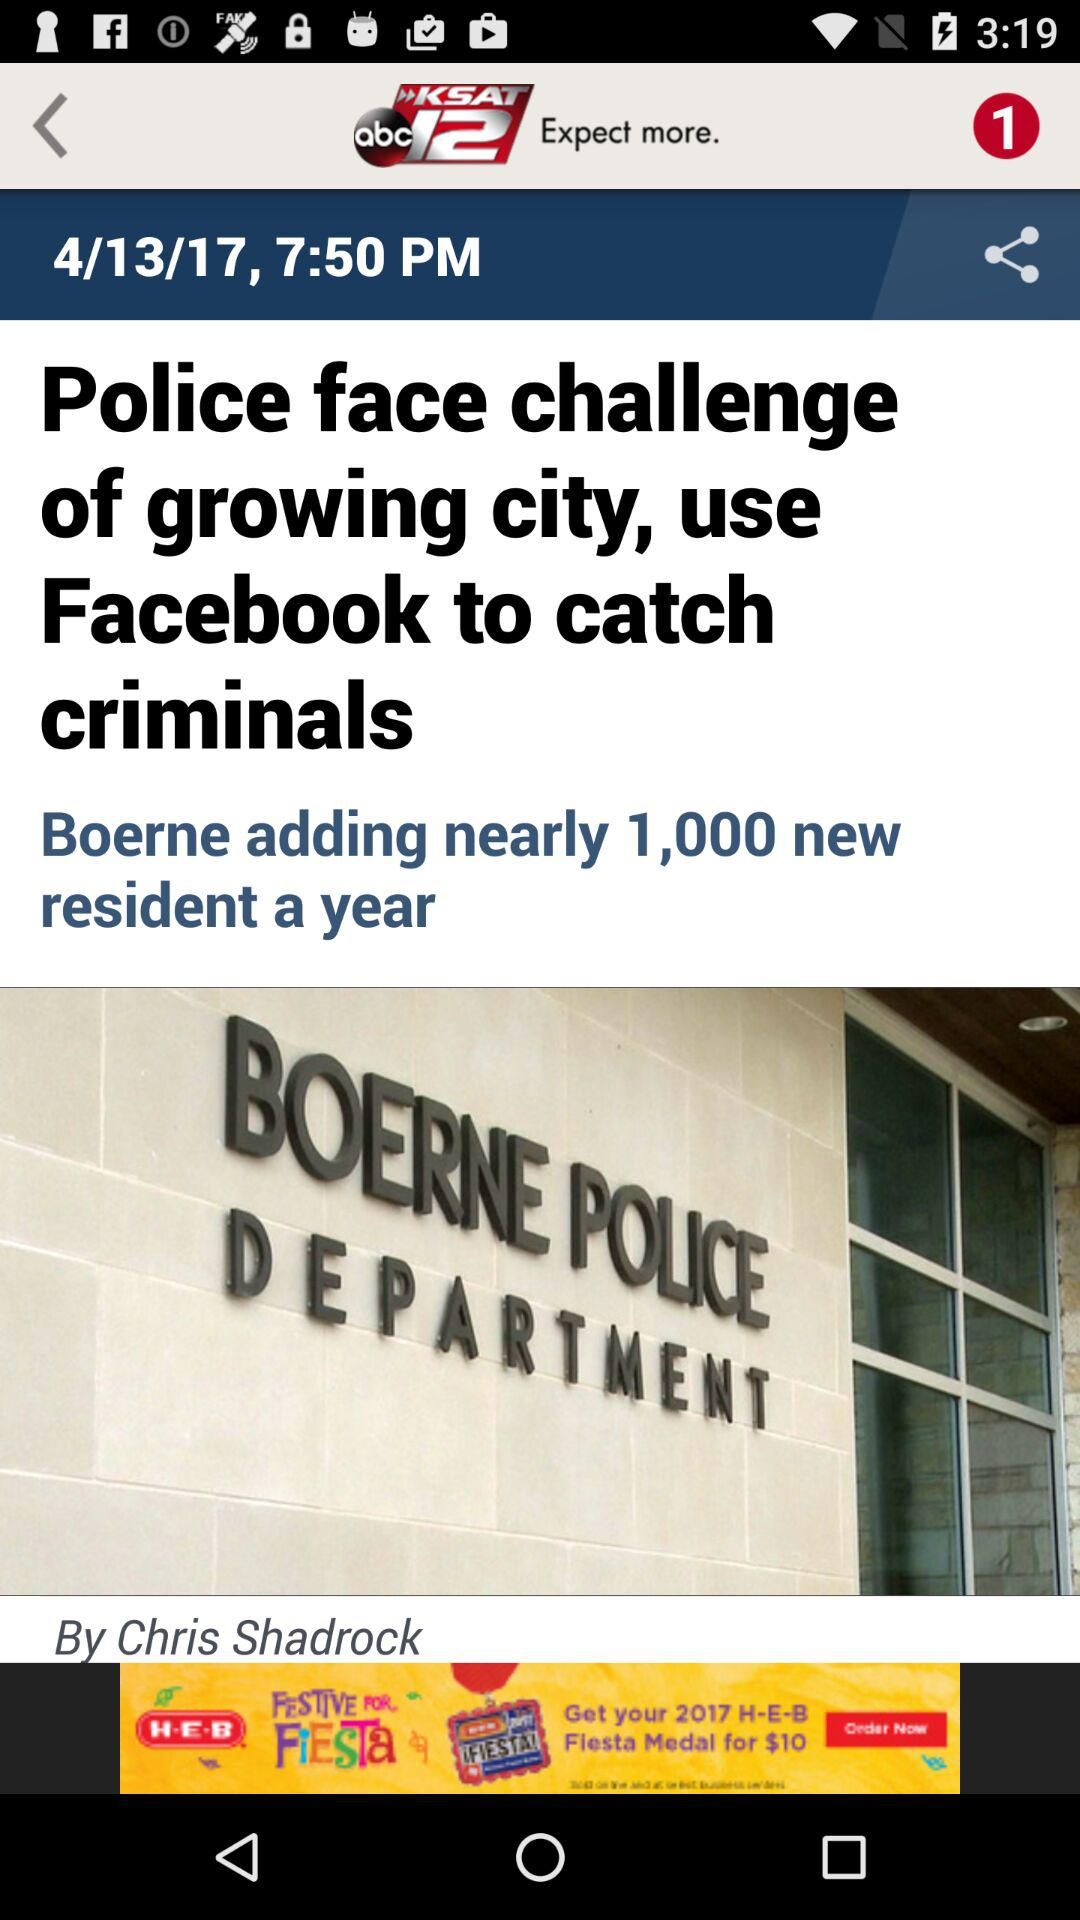How many new residents is Boerne adding? Boerne is adding nearly 1,000 new residents. 